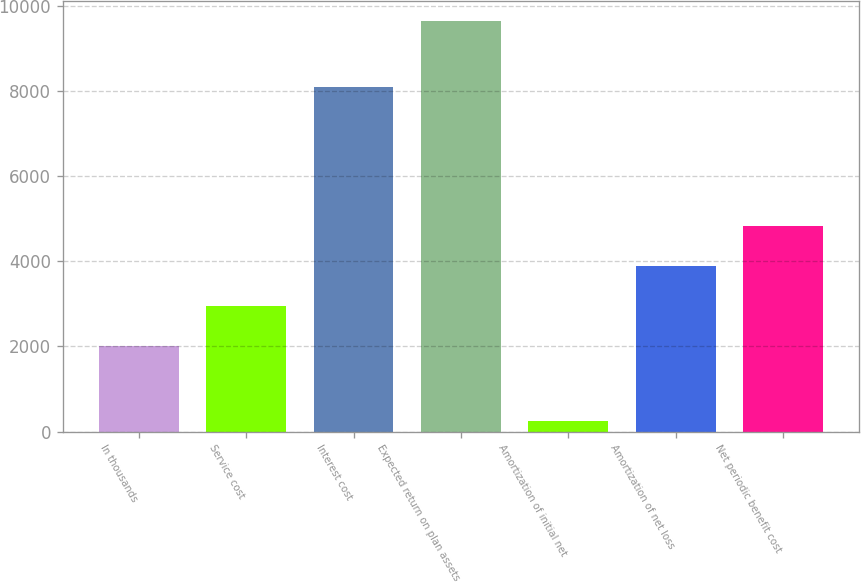<chart> <loc_0><loc_0><loc_500><loc_500><bar_chart><fcel>In thousands<fcel>Service cost<fcel>Interest cost<fcel>Expected return on plan assets<fcel>Amortization of initial net<fcel>Amortization of net loss<fcel>Net periodic benefit cost<nl><fcel>2014<fcel>2953.8<fcel>8102<fcel>9646<fcel>248<fcel>3893.6<fcel>4833.4<nl></chart> 